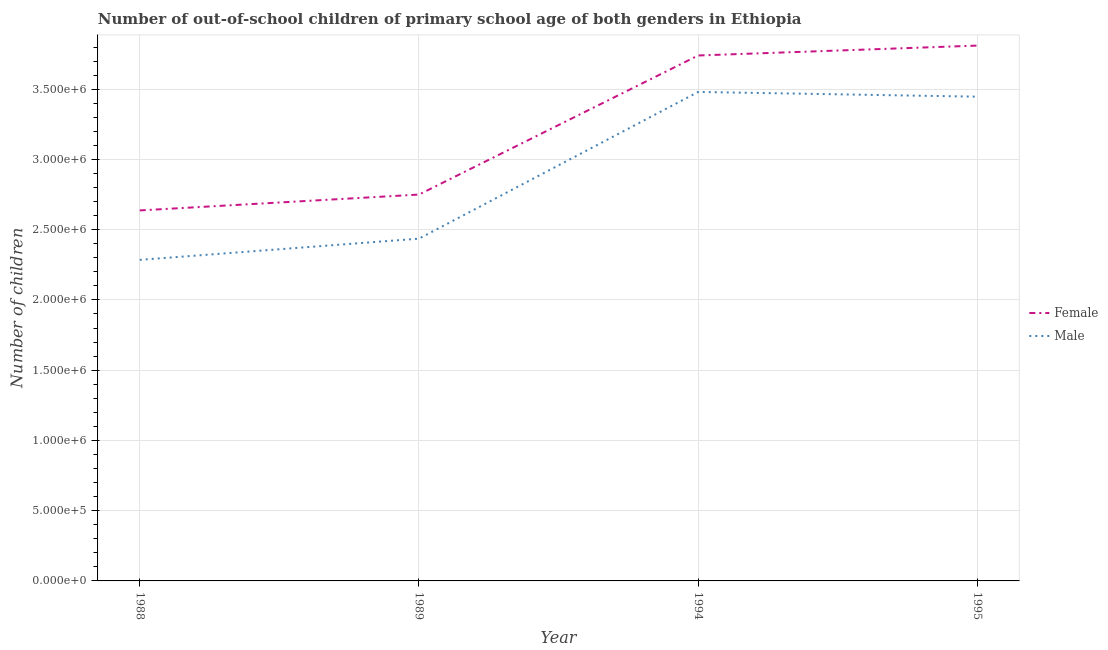Does the line corresponding to number of female out-of-school students intersect with the line corresponding to number of male out-of-school students?
Offer a very short reply. No. What is the number of male out-of-school students in 1988?
Make the answer very short. 2.29e+06. Across all years, what is the maximum number of male out-of-school students?
Keep it short and to the point. 3.48e+06. Across all years, what is the minimum number of female out-of-school students?
Your answer should be very brief. 2.64e+06. What is the total number of male out-of-school students in the graph?
Provide a short and direct response. 1.16e+07. What is the difference between the number of female out-of-school students in 1989 and that in 1994?
Offer a very short reply. -9.90e+05. What is the difference between the number of female out-of-school students in 1994 and the number of male out-of-school students in 1988?
Keep it short and to the point. 1.45e+06. What is the average number of female out-of-school students per year?
Offer a very short reply. 3.23e+06. In the year 1995, what is the difference between the number of female out-of-school students and number of male out-of-school students?
Offer a terse response. 3.64e+05. In how many years, is the number of male out-of-school students greater than 2600000?
Your answer should be very brief. 2. What is the ratio of the number of female out-of-school students in 1988 to that in 1995?
Provide a succinct answer. 0.69. Is the number of female out-of-school students in 1994 less than that in 1995?
Provide a succinct answer. Yes. What is the difference between the highest and the second highest number of male out-of-school students?
Give a very brief answer. 3.39e+04. What is the difference between the highest and the lowest number of female out-of-school students?
Make the answer very short. 1.17e+06. Is the number of male out-of-school students strictly greater than the number of female out-of-school students over the years?
Ensure brevity in your answer.  No. Is the number of female out-of-school students strictly less than the number of male out-of-school students over the years?
Your answer should be very brief. No. How many years are there in the graph?
Ensure brevity in your answer.  4. Are the values on the major ticks of Y-axis written in scientific E-notation?
Your answer should be very brief. Yes. Does the graph contain any zero values?
Ensure brevity in your answer.  No. Where does the legend appear in the graph?
Keep it short and to the point. Center right. How many legend labels are there?
Give a very brief answer. 2. How are the legend labels stacked?
Keep it short and to the point. Vertical. What is the title of the graph?
Offer a very short reply. Number of out-of-school children of primary school age of both genders in Ethiopia. What is the label or title of the Y-axis?
Your answer should be compact. Number of children. What is the Number of children of Female in 1988?
Ensure brevity in your answer.  2.64e+06. What is the Number of children in Male in 1988?
Your answer should be very brief. 2.29e+06. What is the Number of children in Female in 1989?
Offer a terse response. 2.75e+06. What is the Number of children in Male in 1989?
Offer a terse response. 2.44e+06. What is the Number of children of Female in 1994?
Ensure brevity in your answer.  3.74e+06. What is the Number of children in Male in 1994?
Your answer should be compact. 3.48e+06. What is the Number of children in Female in 1995?
Keep it short and to the point. 3.81e+06. What is the Number of children in Male in 1995?
Your response must be concise. 3.45e+06. Across all years, what is the maximum Number of children in Female?
Make the answer very short. 3.81e+06. Across all years, what is the maximum Number of children of Male?
Offer a very short reply. 3.48e+06. Across all years, what is the minimum Number of children in Female?
Your response must be concise. 2.64e+06. Across all years, what is the minimum Number of children of Male?
Your response must be concise. 2.29e+06. What is the total Number of children of Female in the graph?
Ensure brevity in your answer.  1.29e+07. What is the total Number of children in Male in the graph?
Offer a terse response. 1.16e+07. What is the difference between the Number of children of Female in 1988 and that in 1989?
Ensure brevity in your answer.  -1.13e+05. What is the difference between the Number of children of Male in 1988 and that in 1989?
Your answer should be compact. -1.51e+05. What is the difference between the Number of children of Female in 1988 and that in 1994?
Give a very brief answer. -1.10e+06. What is the difference between the Number of children in Male in 1988 and that in 1994?
Your answer should be very brief. -1.20e+06. What is the difference between the Number of children of Female in 1988 and that in 1995?
Your answer should be very brief. -1.17e+06. What is the difference between the Number of children of Male in 1988 and that in 1995?
Give a very brief answer. -1.16e+06. What is the difference between the Number of children of Female in 1989 and that in 1994?
Make the answer very short. -9.90e+05. What is the difference between the Number of children of Male in 1989 and that in 1994?
Keep it short and to the point. -1.04e+06. What is the difference between the Number of children in Female in 1989 and that in 1995?
Your response must be concise. -1.06e+06. What is the difference between the Number of children of Male in 1989 and that in 1995?
Your answer should be compact. -1.01e+06. What is the difference between the Number of children of Female in 1994 and that in 1995?
Keep it short and to the point. -7.05e+04. What is the difference between the Number of children of Male in 1994 and that in 1995?
Your response must be concise. 3.39e+04. What is the difference between the Number of children in Female in 1988 and the Number of children in Male in 1989?
Provide a short and direct response. 2.01e+05. What is the difference between the Number of children in Female in 1988 and the Number of children in Male in 1994?
Offer a very short reply. -8.43e+05. What is the difference between the Number of children of Female in 1988 and the Number of children of Male in 1995?
Ensure brevity in your answer.  -8.10e+05. What is the difference between the Number of children in Female in 1989 and the Number of children in Male in 1994?
Your answer should be compact. -7.31e+05. What is the difference between the Number of children of Female in 1989 and the Number of children of Male in 1995?
Provide a short and direct response. -6.97e+05. What is the difference between the Number of children of Female in 1994 and the Number of children of Male in 1995?
Ensure brevity in your answer.  2.93e+05. What is the average Number of children of Female per year?
Give a very brief answer. 3.23e+06. What is the average Number of children of Male per year?
Ensure brevity in your answer.  2.91e+06. In the year 1988, what is the difference between the Number of children of Female and Number of children of Male?
Offer a terse response. 3.52e+05. In the year 1989, what is the difference between the Number of children of Female and Number of children of Male?
Provide a short and direct response. 3.14e+05. In the year 1994, what is the difference between the Number of children in Female and Number of children in Male?
Keep it short and to the point. 2.59e+05. In the year 1995, what is the difference between the Number of children of Female and Number of children of Male?
Your answer should be compact. 3.64e+05. What is the ratio of the Number of children of Female in 1988 to that in 1989?
Ensure brevity in your answer.  0.96. What is the ratio of the Number of children in Male in 1988 to that in 1989?
Offer a terse response. 0.94. What is the ratio of the Number of children in Female in 1988 to that in 1994?
Give a very brief answer. 0.71. What is the ratio of the Number of children in Male in 1988 to that in 1994?
Your answer should be very brief. 0.66. What is the ratio of the Number of children in Female in 1988 to that in 1995?
Provide a short and direct response. 0.69. What is the ratio of the Number of children in Male in 1988 to that in 1995?
Give a very brief answer. 0.66. What is the ratio of the Number of children of Female in 1989 to that in 1994?
Provide a short and direct response. 0.74. What is the ratio of the Number of children in Female in 1989 to that in 1995?
Your response must be concise. 0.72. What is the ratio of the Number of children of Male in 1989 to that in 1995?
Provide a succinct answer. 0.71. What is the ratio of the Number of children in Female in 1994 to that in 1995?
Your answer should be compact. 0.98. What is the ratio of the Number of children of Male in 1994 to that in 1995?
Offer a terse response. 1.01. What is the difference between the highest and the second highest Number of children in Female?
Offer a very short reply. 7.05e+04. What is the difference between the highest and the second highest Number of children in Male?
Your answer should be very brief. 3.39e+04. What is the difference between the highest and the lowest Number of children in Female?
Make the answer very short. 1.17e+06. What is the difference between the highest and the lowest Number of children of Male?
Ensure brevity in your answer.  1.20e+06. 